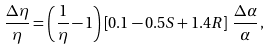<formula> <loc_0><loc_0><loc_500><loc_500>\frac { \Delta \eta } { \eta } = \left ( \frac { 1 } { \eta } - 1 \right ) \left [ 0 . 1 - 0 . 5 S + 1 . 4 R \right ] \, \frac { \Delta \alpha } { \alpha } \, ,</formula> 